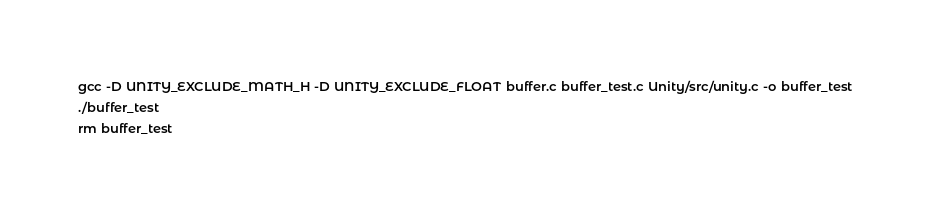<code> <loc_0><loc_0><loc_500><loc_500><_Bash_>gcc -D UNITY_EXCLUDE_MATH_H -D UNITY_EXCLUDE_FLOAT buffer.c buffer_test.c Unity/src/unity.c -o buffer_test
./buffer_test
rm buffer_test
</code> 